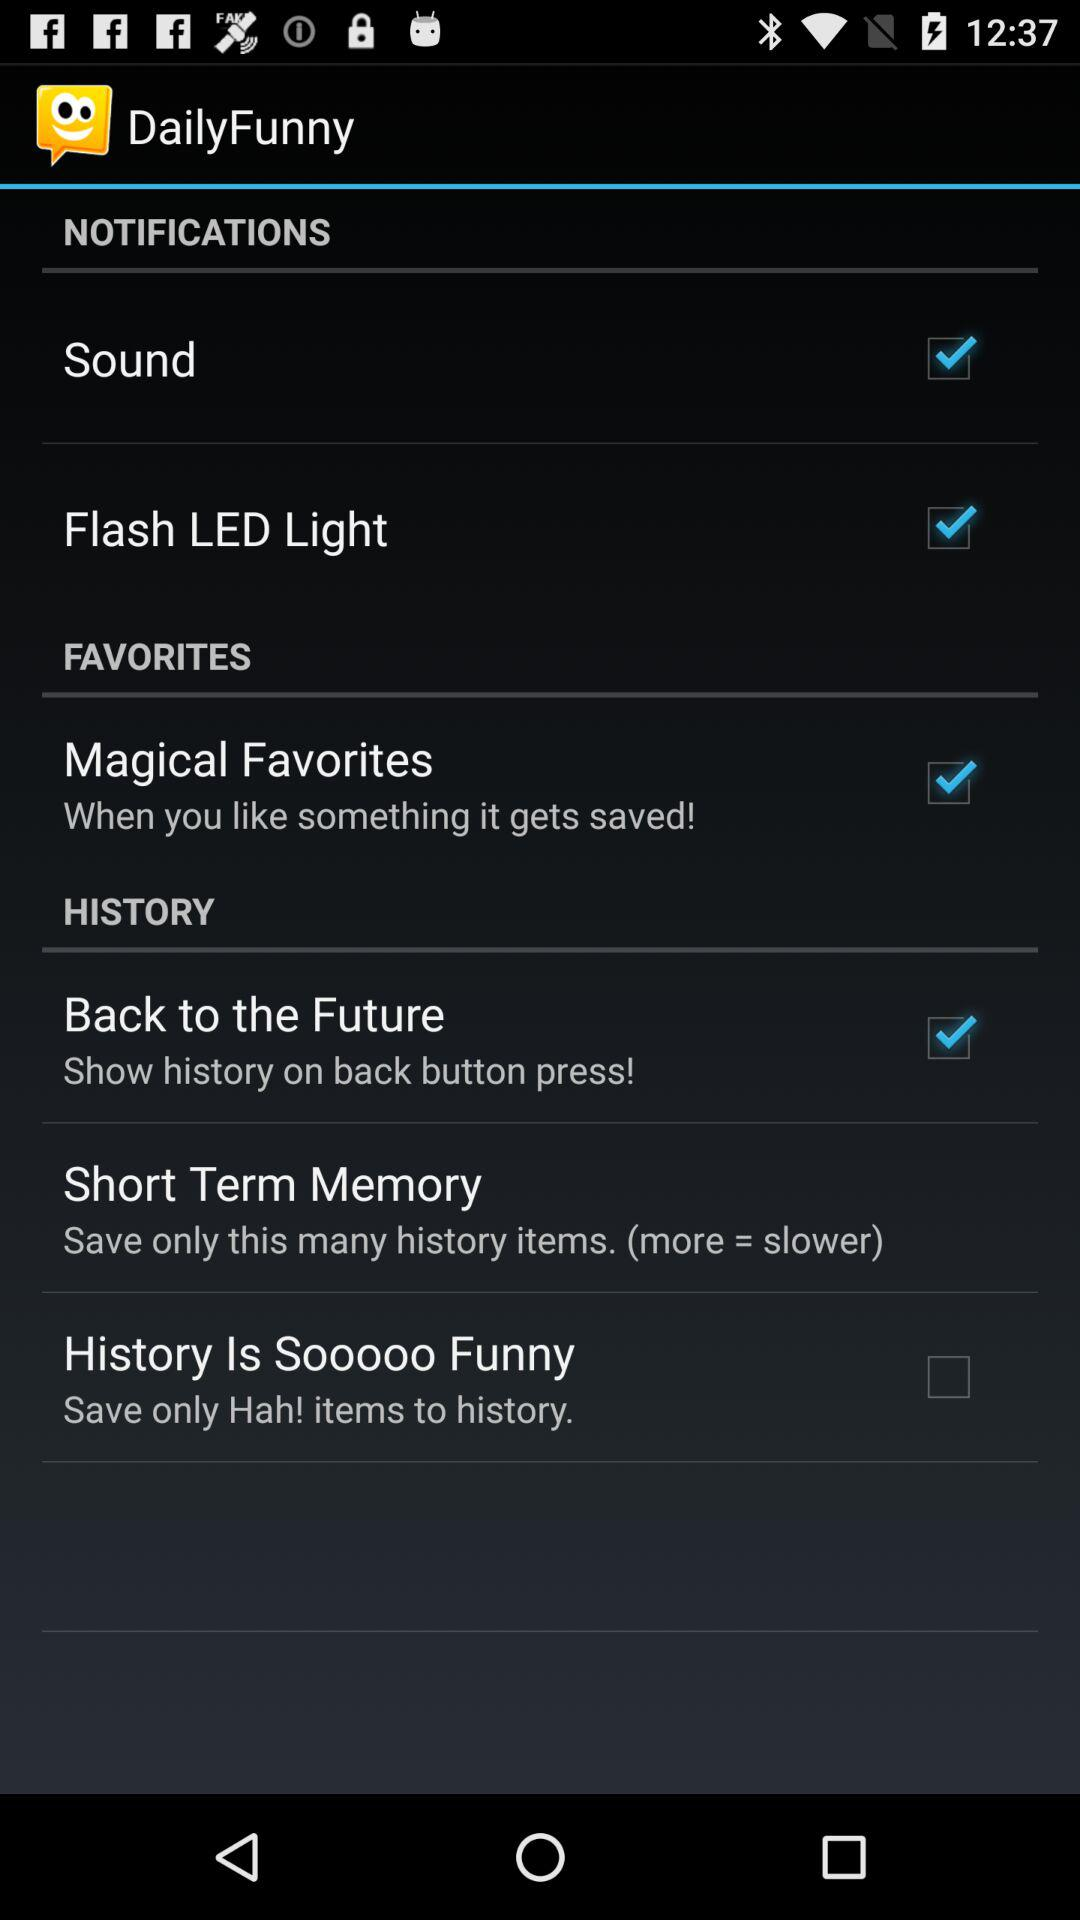Is the "Sound" notification on or off? The "Sound" is on. 